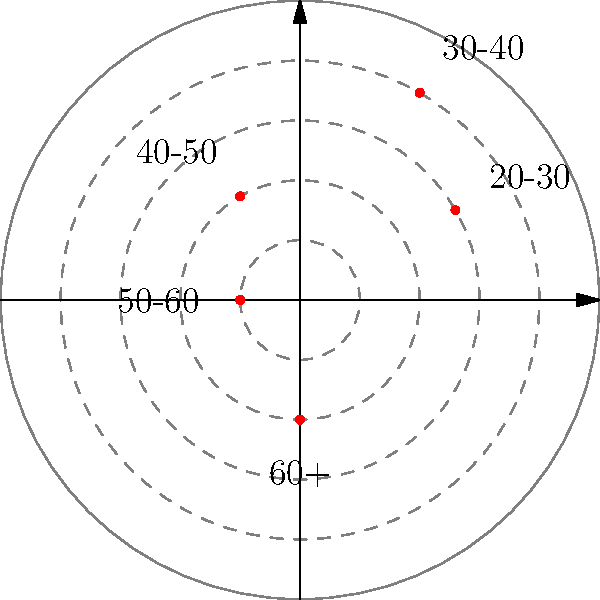A business consultant created a polar scatter plot to represent customer demographics for a new product launch. Each point represents an age group, with the angle indicating the group and the distance from the center showing the relative size of that group in the customer base. Based on the plot, which age group appears to be the largest segment of the customer base? To determine the largest customer segment, we need to analyze the polar scatter plot:

1. Identify the age groups:
   - 20-30: Located at approximately 30 degrees
   - 30-40: Located at approximately 60 degrees
   - 40-50: Located at approximately 120 degrees
   - 50-60: Located at approximately 180 degrees
   - 60+: Located at approximately 270 degrees

2. Compare the distances from the center:
   - 20-30: About 3 units from center
   - 30-40: About 4 units from center
   - 40-50: About 2 units from center
   - 50-60: About 1 unit from center
   - 60+: About 2 units from center

3. Interpret the distances:
   The further a point is from the center, the larger the segment it represents.

4. Identify the point furthest from the center:
   The point representing the 30-40 age group is the furthest from the center at approximately 4 units.

Therefore, the 30-40 age group appears to be the largest segment of the customer base.
Answer: 30-40 age group 